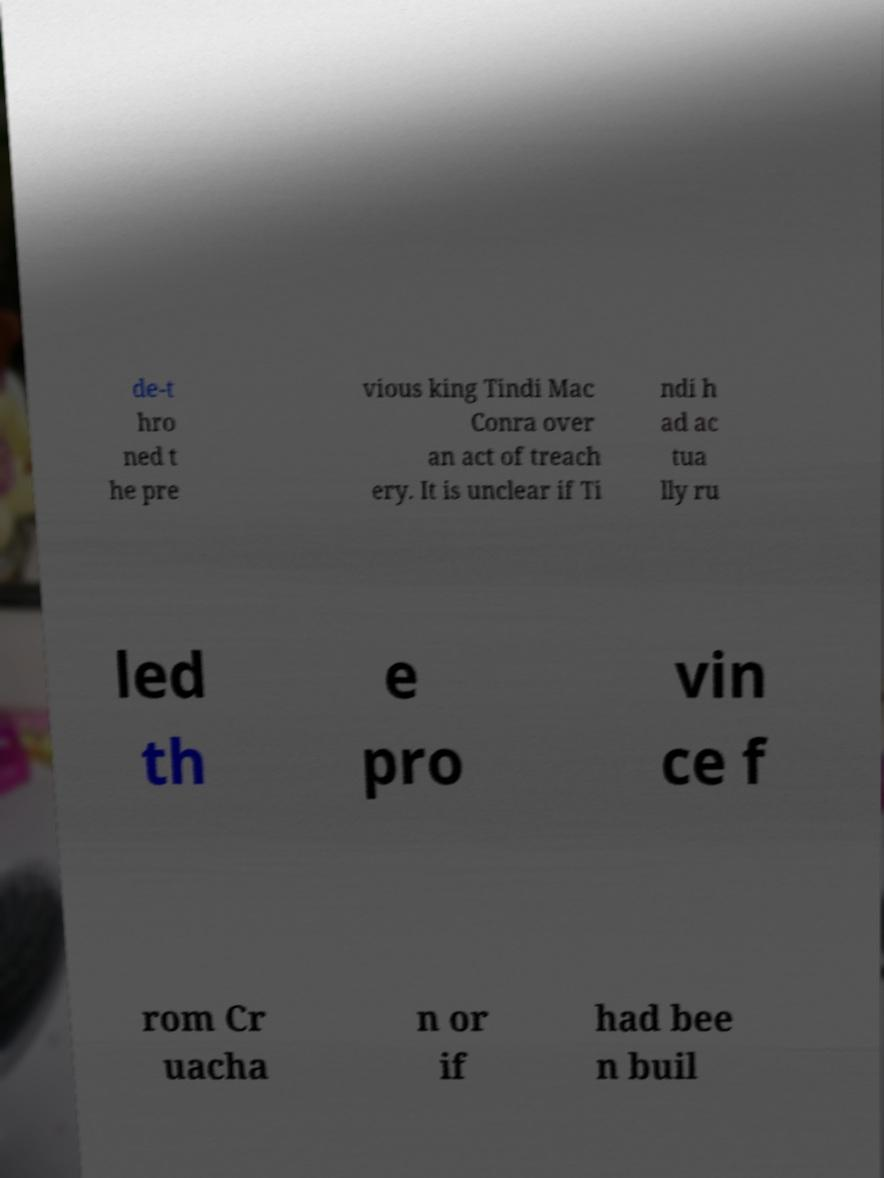Please identify and transcribe the text found in this image. de-t hro ned t he pre vious king Tindi Mac Conra over an act of treach ery. It is unclear if Ti ndi h ad ac tua lly ru led th e pro vin ce f rom Cr uacha n or if had bee n buil 